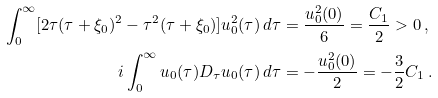<formula> <loc_0><loc_0><loc_500><loc_500>\int _ { 0 } ^ { \infty } [ 2 \tau ( \tau + \xi _ { 0 } ) ^ { 2 } - \tau ^ { 2 } ( \tau + \xi _ { 0 } ) ] u _ { 0 } ^ { 2 } ( \tau ) \, d \tau & = \frac { u _ { 0 } ^ { 2 } ( 0 ) } { 6 } = \frac { C _ { 1 } } { 2 } > 0 \, , \\ i \int _ { 0 } ^ { \infty } u _ { 0 } ( \tau ) D _ { \tau } u _ { 0 } ( \tau ) \, d \tau & = - \frac { u _ { 0 } ^ { 2 } ( 0 ) } { 2 } = - \frac { 3 } { 2 } C _ { 1 } \, .</formula> 